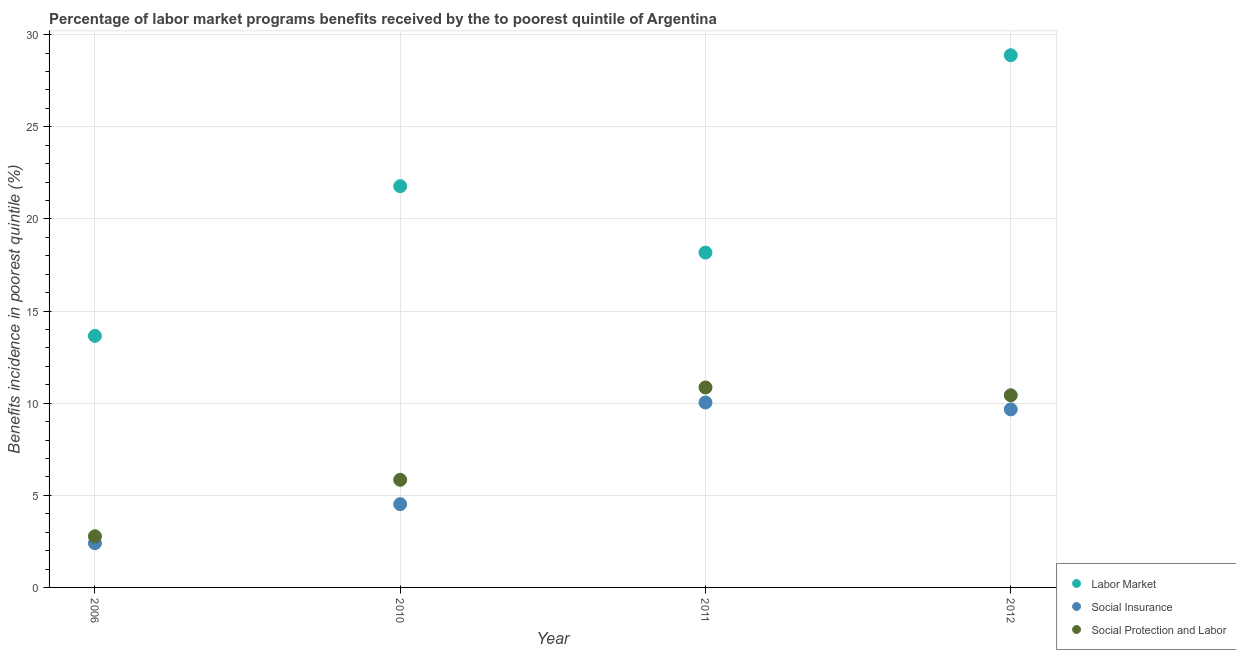How many different coloured dotlines are there?
Offer a very short reply. 3. Is the number of dotlines equal to the number of legend labels?
Provide a succinct answer. Yes. What is the percentage of benefits received due to social protection programs in 2011?
Provide a succinct answer. 10.85. Across all years, what is the maximum percentage of benefits received due to social protection programs?
Give a very brief answer. 10.85. Across all years, what is the minimum percentage of benefits received due to social protection programs?
Offer a very short reply. 2.78. What is the total percentage of benefits received due to social insurance programs in the graph?
Your answer should be compact. 26.62. What is the difference between the percentage of benefits received due to social insurance programs in 2006 and that in 2011?
Give a very brief answer. -7.64. What is the difference between the percentage of benefits received due to social protection programs in 2011 and the percentage of benefits received due to labor market programs in 2006?
Give a very brief answer. -2.8. What is the average percentage of benefits received due to social insurance programs per year?
Keep it short and to the point. 6.65. In the year 2011, what is the difference between the percentage of benefits received due to social insurance programs and percentage of benefits received due to social protection programs?
Make the answer very short. -0.81. In how many years, is the percentage of benefits received due to labor market programs greater than 17 %?
Make the answer very short. 3. What is the ratio of the percentage of benefits received due to social protection programs in 2006 to that in 2010?
Provide a succinct answer. 0.48. Is the difference between the percentage of benefits received due to social insurance programs in 2010 and 2012 greater than the difference between the percentage of benefits received due to social protection programs in 2010 and 2012?
Provide a short and direct response. No. What is the difference between the highest and the second highest percentage of benefits received due to labor market programs?
Offer a terse response. 7.11. What is the difference between the highest and the lowest percentage of benefits received due to social insurance programs?
Give a very brief answer. 7.64. Is it the case that in every year, the sum of the percentage of benefits received due to labor market programs and percentage of benefits received due to social insurance programs is greater than the percentage of benefits received due to social protection programs?
Provide a succinct answer. Yes. Is the percentage of benefits received due to social insurance programs strictly greater than the percentage of benefits received due to labor market programs over the years?
Provide a succinct answer. No. Is the percentage of benefits received due to social protection programs strictly less than the percentage of benefits received due to labor market programs over the years?
Provide a short and direct response. Yes. How many years are there in the graph?
Offer a terse response. 4. Are the values on the major ticks of Y-axis written in scientific E-notation?
Provide a succinct answer. No. Does the graph contain any zero values?
Provide a succinct answer. No. Does the graph contain grids?
Ensure brevity in your answer.  Yes. How are the legend labels stacked?
Ensure brevity in your answer.  Vertical. What is the title of the graph?
Keep it short and to the point. Percentage of labor market programs benefits received by the to poorest quintile of Argentina. What is the label or title of the X-axis?
Your answer should be compact. Year. What is the label or title of the Y-axis?
Ensure brevity in your answer.  Benefits incidence in poorest quintile (%). What is the Benefits incidence in poorest quintile (%) of Labor Market in 2006?
Ensure brevity in your answer.  13.65. What is the Benefits incidence in poorest quintile (%) of Social Insurance in 2006?
Your answer should be very brief. 2.4. What is the Benefits incidence in poorest quintile (%) in Social Protection and Labor in 2006?
Offer a very short reply. 2.78. What is the Benefits incidence in poorest quintile (%) in Labor Market in 2010?
Your response must be concise. 21.78. What is the Benefits incidence in poorest quintile (%) in Social Insurance in 2010?
Keep it short and to the point. 4.52. What is the Benefits incidence in poorest quintile (%) of Social Protection and Labor in 2010?
Ensure brevity in your answer.  5.84. What is the Benefits incidence in poorest quintile (%) in Labor Market in 2011?
Make the answer very short. 18.17. What is the Benefits incidence in poorest quintile (%) in Social Insurance in 2011?
Your answer should be compact. 10.04. What is the Benefits incidence in poorest quintile (%) of Social Protection and Labor in 2011?
Provide a short and direct response. 10.85. What is the Benefits incidence in poorest quintile (%) of Labor Market in 2012?
Give a very brief answer. 28.88. What is the Benefits incidence in poorest quintile (%) in Social Insurance in 2012?
Provide a short and direct response. 9.66. What is the Benefits incidence in poorest quintile (%) of Social Protection and Labor in 2012?
Offer a terse response. 10.43. Across all years, what is the maximum Benefits incidence in poorest quintile (%) in Labor Market?
Keep it short and to the point. 28.88. Across all years, what is the maximum Benefits incidence in poorest quintile (%) in Social Insurance?
Provide a succinct answer. 10.04. Across all years, what is the maximum Benefits incidence in poorest quintile (%) of Social Protection and Labor?
Keep it short and to the point. 10.85. Across all years, what is the minimum Benefits incidence in poorest quintile (%) in Labor Market?
Make the answer very short. 13.65. Across all years, what is the minimum Benefits incidence in poorest quintile (%) of Social Insurance?
Keep it short and to the point. 2.4. Across all years, what is the minimum Benefits incidence in poorest quintile (%) of Social Protection and Labor?
Your response must be concise. 2.78. What is the total Benefits incidence in poorest quintile (%) in Labor Market in the graph?
Your response must be concise. 82.48. What is the total Benefits incidence in poorest quintile (%) of Social Insurance in the graph?
Offer a very short reply. 26.62. What is the total Benefits incidence in poorest quintile (%) of Social Protection and Labor in the graph?
Your answer should be very brief. 29.9. What is the difference between the Benefits incidence in poorest quintile (%) in Labor Market in 2006 and that in 2010?
Give a very brief answer. -8.12. What is the difference between the Benefits incidence in poorest quintile (%) of Social Insurance in 2006 and that in 2010?
Provide a succinct answer. -2.12. What is the difference between the Benefits incidence in poorest quintile (%) of Social Protection and Labor in 2006 and that in 2010?
Provide a short and direct response. -3.06. What is the difference between the Benefits incidence in poorest quintile (%) in Labor Market in 2006 and that in 2011?
Your answer should be very brief. -4.52. What is the difference between the Benefits incidence in poorest quintile (%) of Social Insurance in 2006 and that in 2011?
Provide a short and direct response. -7.64. What is the difference between the Benefits incidence in poorest quintile (%) of Social Protection and Labor in 2006 and that in 2011?
Your answer should be compact. -8.07. What is the difference between the Benefits incidence in poorest quintile (%) of Labor Market in 2006 and that in 2012?
Make the answer very short. -15.23. What is the difference between the Benefits incidence in poorest quintile (%) of Social Insurance in 2006 and that in 2012?
Make the answer very short. -7.26. What is the difference between the Benefits incidence in poorest quintile (%) in Social Protection and Labor in 2006 and that in 2012?
Your answer should be very brief. -7.65. What is the difference between the Benefits incidence in poorest quintile (%) in Labor Market in 2010 and that in 2011?
Make the answer very short. 3.6. What is the difference between the Benefits incidence in poorest quintile (%) of Social Insurance in 2010 and that in 2011?
Offer a terse response. -5.52. What is the difference between the Benefits incidence in poorest quintile (%) in Social Protection and Labor in 2010 and that in 2011?
Offer a very short reply. -5.01. What is the difference between the Benefits incidence in poorest quintile (%) of Labor Market in 2010 and that in 2012?
Your response must be concise. -7.11. What is the difference between the Benefits incidence in poorest quintile (%) in Social Insurance in 2010 and that in 2012?
Provide a succinct answer. -5.14. What is the difference between the Benefits incidence in poorest quintile (%) of Social Protection and Labor in 2010 and that in 2012?
Offer a terse response. -4.59. What is the difference between the Benefits incidence in poorest quintile (%) in Labor Market in 2011 and that in 2012?
Ensure brevity in your answer.  -10.71. What is the difference between the Benefits incidence in poorest quintile (%) of Social Insurance in 2011 and that in 2012?
Your response must be concise. 0.37. What is the difference between the Benefits incidence in poorest quintile (%) of Social Protection and Labor in 2011 and that in 2012?
Give a very brief answer. 0.42. What is the difference between the Benefits incidence in poorest quintile (%) of Labor Market in 2006 and the Benefits incidence in poorest quintile (%) of Social Insurance in 2010?
Offer a very short reply. 9.13. What is the difference between the Benefits incidence in poorest quintile (%) in Labor Market in 2006 and the Benefits incidence in poorest quintile (%) in Social Protection and Labor in 2010?
Make the answer very short. 7.81. What is the difference between the Benefits incidence in poorest quintile (%) in Social Insurance in 2006 and the Benefits incidence in poorest quintile (%) in Social Protection and Labor in 2010?
Keep it short and to the point. -3.44. What is the difference between the Benefits incidence in poorest quintile (%) in Labor Market in 2006 and the Benefits incidence in poorest quintile (%) in Social Insurance in 2011?
Give a very brief answer. 3.62. What is the difference between the Benefits incidence in poorest quintile (%) of Labor Market in 2006 and the Benefits incidence in poorest quintile (%) of Social Protection and Labor in 2011?
Make the answer very short. 2.8. What is the difference between the Benefits incidence in poorest quintile (%) in Social Insurance in 2006 and the Benefits incidence in poorest quintile (%) in Social Protection and Labor in 2011?
Offer a terse response. -8.45. What is the difference between the Benefits incidence in poorest quintile (%) in Labor Market in 2006 and the Benefits incidence in poorest quintile (%) in Social Insurance in 2012?
Offer a very short reply. 3.99. What is the difference between the Benefits incidence in poorest quintile (%) in Labor Market in 2006 and the Benefits incidence in poorest quintile (%) in Social Protection and Labor in 2012?
Keep it short and to the point. 3.22. What is the difference between the Benefits incidence in poorest quintile (%) of Social Insurance in 2006 and the Benefits incidence in poorest quintile (%) of Social Protection and Labor in 2012?
Your answer should be very brief. -8.03. What is the difference between the Benefits incidence in poorest quintile (%) in Labor Market in 2010 and the Benefits incidence in poorest quintile (%) in Social Insurance in 2011?
Give a very brief answer. 11.74. What is the difference between the Benefits incidence in poorest quintile (%) of Labor Market in 2010 and the Benefits incidence in poorest quintile (%) of Social Protection and Labor in 2011?
Your answer should be very brief. 10.93. What is the difference between the Benefits incidence in poorest quintile (%) in Social Insurance in 2010 and the Benefits incidence in poorest quintile (%) in Social Protection and Labor in 2011?
Your answer should be compact. -6.33. What is the difference between the Benefits incidence in poorest quintile (%) in Labor Market in 2010 and the Benefits incidence in poorest quintile (%) in Social Insurance in 2012?
Your answer should be compact. 12.11. What is the difference between the Benefits incidence in poorest quintile (%) of Labor Market in 2010 and the Benefits incidence in poorest quintile (%) of Social Protection and Labor in 2012?
Provide a short and direct response. 11.35. What is the difference between the Benefits incidence in poorest quintile (%) in Social Insurance in 2010 and the Benefits incidence in poorest quintile (%) in Social Protection and Labor in 2012?
Your response must be concise. -5.91. What is the difference between the Benefits incidence in poorest quintile (%) in Labor Market in 2011 and the Benefits incidence in poorest quintile (%) in Social Insurance in 2012?
Offer a terse response. 8.51. What is the difference between the Benefits incidence in poorest quintile (%) in Labor Market in 2011 and the Benefits incidence in poorest quintile (%) in Social Protection and Labor in 2012?
Your response must be concise. 7.74. What is the difference between the Benefits incidence in poorest quintile (%) in Social Insurance in 2011 and the Benefits incidence in poorest quintile (%) in Social Protection and Labor in 2012?
Make the answer very short. -0.39. What is the average Benefits incidence in poorest quintile (%) in Labor Market per year?
Your answer should be compact. 20.62. What is the average Benefits incidence in poorest quintile (%) of Social Insurance per year?
Your answer should be very brief. 6.65. What is the average Benefits incidence in poorest quintile (%) of Social Protection and Labor per year?
Offer a terse response. 7.47. In the year 2006, what is the difference between the Benefits incidence in poorest quintile (%) of Labor Market and Benefits incidence in poorest quintile (%) of Social Insurance?
Provide a succinct answer. 11.25. In the year 2006, what is the difference between the Benefits incidence in poorest quintile (%) in Labor Market and Benefits incidence in poorest quintile (%) in Social Protection and Labor?
Give a very brief answer. 10.88. In the year 2006, what is the difference between the Benefits incidence in poorest quintile (%) of Social Insurance and Benefits incidence in poorest quintile (%) of Social Protection and Labor?
Your answer should be compact. -0.38. In the year 2010, what is the difference between the Benefits incidence in poorest quintile (%) in Labor Market and Benefits incidence in poorest quintile (%) in Social Insurance?
Offer a very short reply. 17.26. In the year 2010, what is the difference between the Benefits incidence in poorest quintile (%) in Labor Market and Benefits incidence in poorest quintile (%) in Social Protection and Labor?
Offer a terse response. 15.94. In the year 2010, what is the difference between the Benefits incidence in poorest quintile (%) of Social Insurance and Benefits incidence in poorest quintile (%) of Social Protection and Labor?
Provide a short and direct response. -1.32. In the year 2011, what is the difference between the Benefits incidence in poorest quintile (%) of Labor Market and Benefits incidence in poorest quintile (%) of Social Insurance?
Offer a very short reply. 8.14. In the year 2011, what is the difference between the Benefits incidence in poorest quintile (%) of Labor Market and Benefits incidence in poorest quintile (%) of Social Protection and Labor?
Make the answer very short. 7.32. In the year 2011, what is the difference between the Benefits incidence in poorest quintile (%) in Social Insurance and Benefits incidence in poorest quintile (%) in Social Protection and Labor?
Your answer should be very brief. -0.81. In the year 2012, what is the difference between the Benefits incidence in poorest quintile (%) of Labor Market and Benefits incidence in poorest quintile (%) of Social Insurance?
Your answer should be very brief. 19.22. In the year 2012, what is the difference between the Benefits incidence in poorest quintile (%) of Labor Market and Benefits incidence in poorest quintile (%) of Social Protection and Labor?
Offer a very short reply. 18.45. In the year 2012, what is the difference between the Benefits incidence in poorest quintile (%) of Social Insurance and Benefits incidence in poorest quintile (%) of Social Protection and Labor?
Your response must be concise. -0.77. What is the ratio of the Benefits incidence in poorest quintile (%) of Labor Market in 2006 to that in 2010?
Make the answer very short. 0.63. What is the ratio of the Benefits incidence in poorest quintile (%) of Social Insurance in 2006 to that in 2010?
Make the answer very short. 0.53. What is the ratio of the Benefits incidence in poorest quintile (%) of Social Protection and Labor in 2006 to that in 2010?
Offer a very short reply. 0.48. What is the ratio of the Benefits incidence in poorest quintile (%) in Labor Market in 2006 to that in 2011?
Offer a very short reply. 0.75. What is the ratio of the Benefits incidence in poorest quintile (%) of Social Insurance in 2006 to that in 2011?
Keep it short and to the point. 0.24. What is the ratio of the Benefits incidence in poorest quintile (%) of Social Protection and Labor in 2006 to that in 2011?
Give a very brief answer. 0.26. What is the ratio of the Benefits incidence in poorest quintile (%) in Labor Market in 2006 to that in 2012?
Provide a short and direct response. 0.47. What is the ratio of the Benefits incidence in poorest quintile (%) of Social Insurance in 2006 to that in 2012?
Make the answer very short. 0.25. What is the ratio of the Benefits incidence in poorest quintile (%) in Social Protection and Labor in 2006 to that in 2012?
Offer a very short reply. 0.27. What is the ratio of the Benefits incidence in poorest quintile (%) in Labor Market in 2010 to that in 2011?
Your answer should be compact. 1.2. What is the ratio of the Benefits incidence in poorest quintile (%) in Social Insurance in 2010 to that in 2011?
Your answer should be very brief. 0.45. What is the ratio of the Benefits incidence in poorest quintile (%) of Social Protection and Labor in 2010 to that in 2011?
Your answer should be compact. 0.54. What is the ratio of the Benefits incidence in poorest quintile (%) in Labor Market in 2010 to that in 2012?
Provide a succinct answer. 0.75. What is the ratio of the Benefits incidence in poorest quintile (%) of Social Insurance in 2010 to that in 2012?
Your answer should be very brief. 0.47. What is the ratio of the Benefits incidence in poorest quintile (%) of Social Protection and Labor in 2010 to that in 2012?
Offer a very short reply. 0.56. What is the ratio of the Benefits incidence in poorest quintile (%) of Labor Market in 2011 to that in 2012?
Your answer should be compact. 0.63. What is the ratio of the Benefits incidence in poorest quintile (%) of Social Insurance in 2011 to that in 2012?
Give a very brief answer. 1.04. What is the ratio of the Benefits incidence in poorest quintile (%) of Social Protection and Labor in 2011 to that in 2012?
Give a very brief answer. 1.04. What is the difference between the highest and the second highest Benefits incidence in poorest quintile (%) of Labor Market?
Your answer should be compact. 7.11. What is the difference between the highest and the second highest Benefits incidence in poorest quintile (%) in Social Insurance?
Make the answer very short. 0.37. What is the difference between the highest and the second highest Benefits incidence in poorest quintile (%) of Social Protection and Labor?
Offer a terse response. 0.42. What is the difference between the highest and the lowest Benefits incidence in poorest quintile (%) of Labor Market?
Offer a terse response. 15.23. What is the difference between the highest and the lowest Benefits incidence in poorest quintile (%) in Social Insurance?
Your answer should be compact. 7.64. What is the difference between the highest and the lowest Benefits incidence in poorest quintile (%) in Social Protection and Labor?
Ensure brevity in your answer.  8.07. 